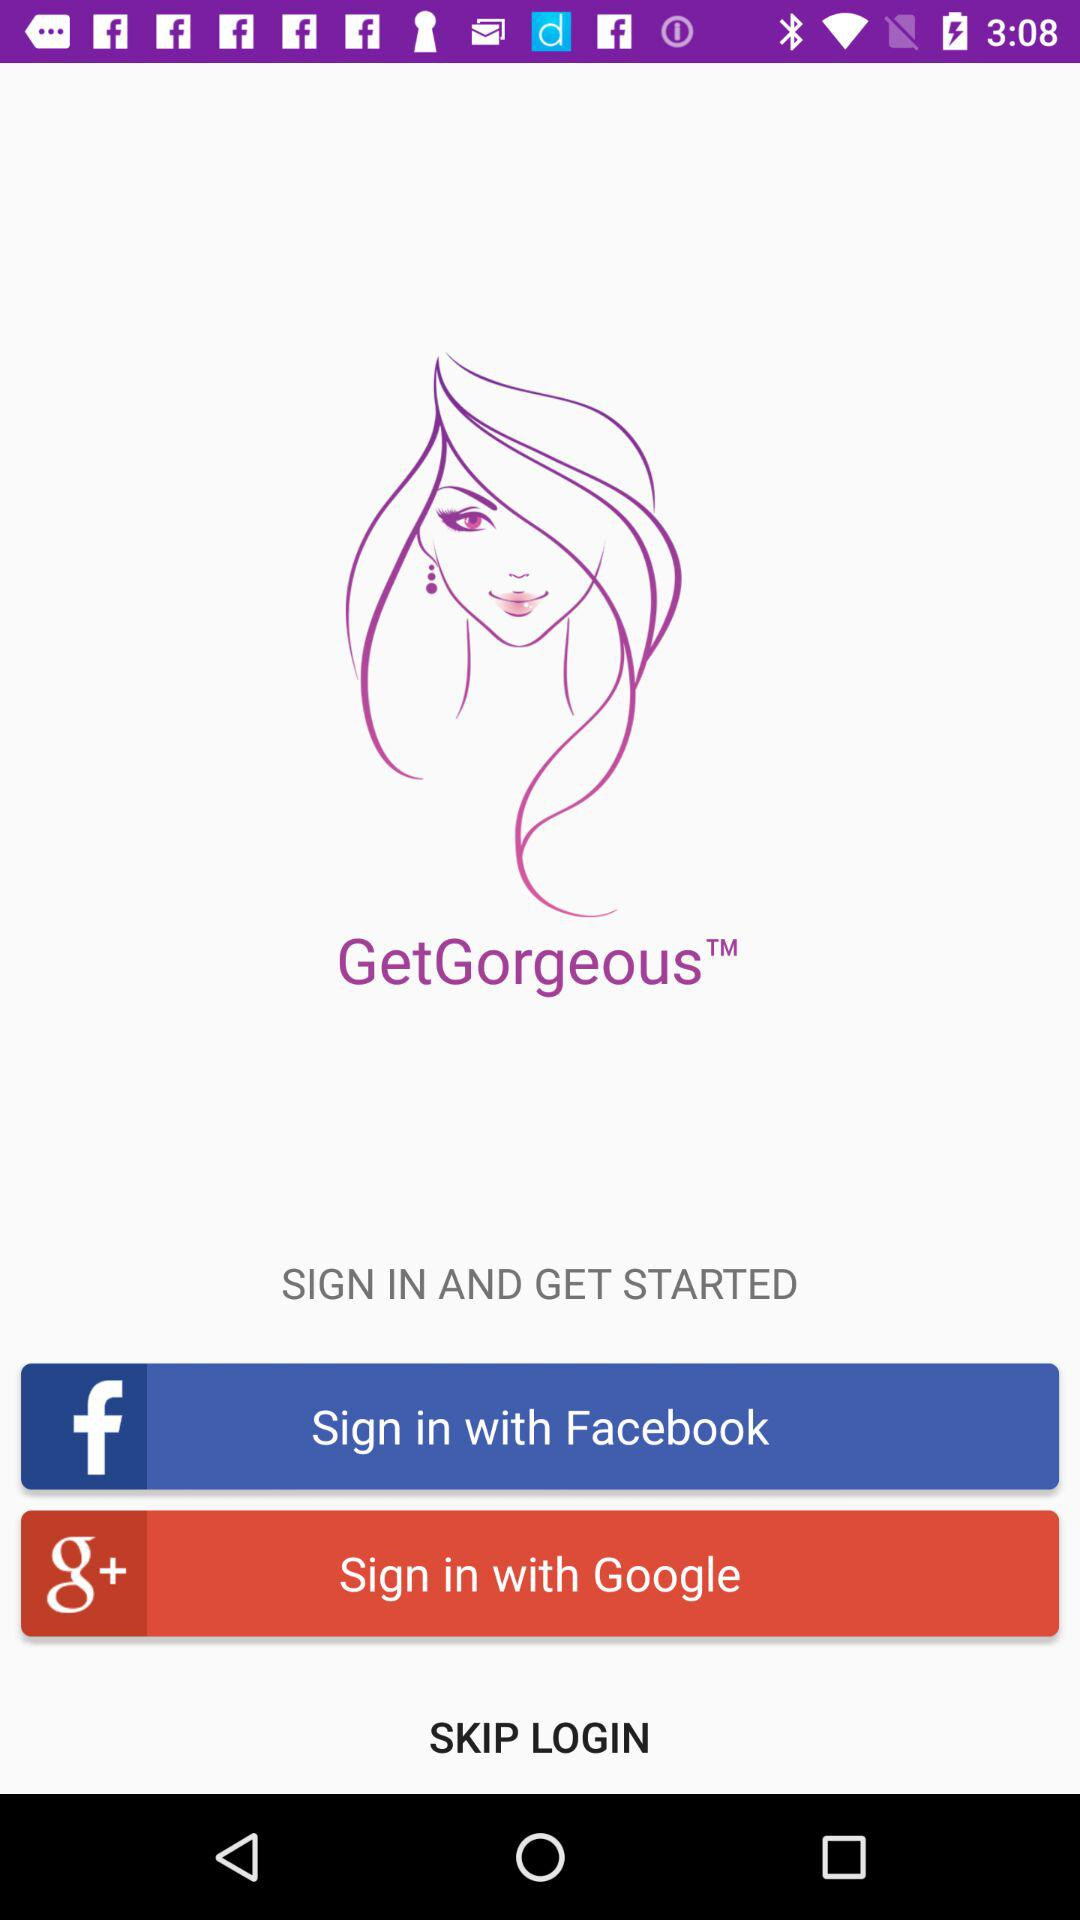What is the name of the application? The name of the application is "GetGorgeous". 